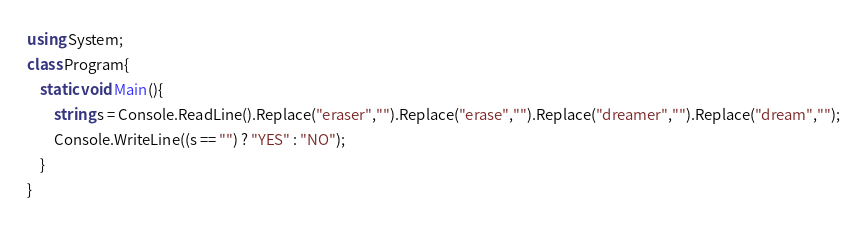<code> <loc_0><loc_0><loc_500><loc_500><_C#_>using System;
class Program{
    static void Main(){
        string s = Console.ReadLine().Replace("eraser","").Replace("erase","").Replace("dreamer","").Replace("dream","");
        Console.WriteLine((s == "") ? "YES" : "NO");
    }
}</code> 